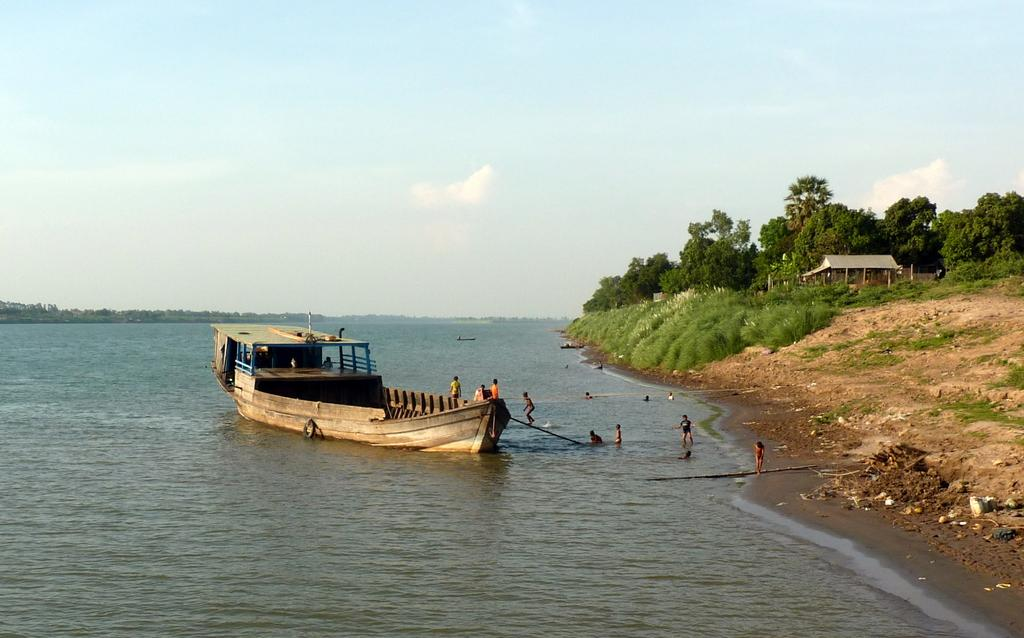What is the primary element in the image? There is water in the image. What else can be seen in the water? There are boats in the image. Who or what is present near the water? There are people in the image. What type of vegetation is visible in the image? There are trees, plants, and grass in the image. What type of structure is present in the image? There is a building in the image. What can be seen in the background of the image? The sky is visible in the background of the image. What type of appliance can be seen in the image? There is no appliance present in the image. What type of window can be seen in the image? There is no window present in the image. 